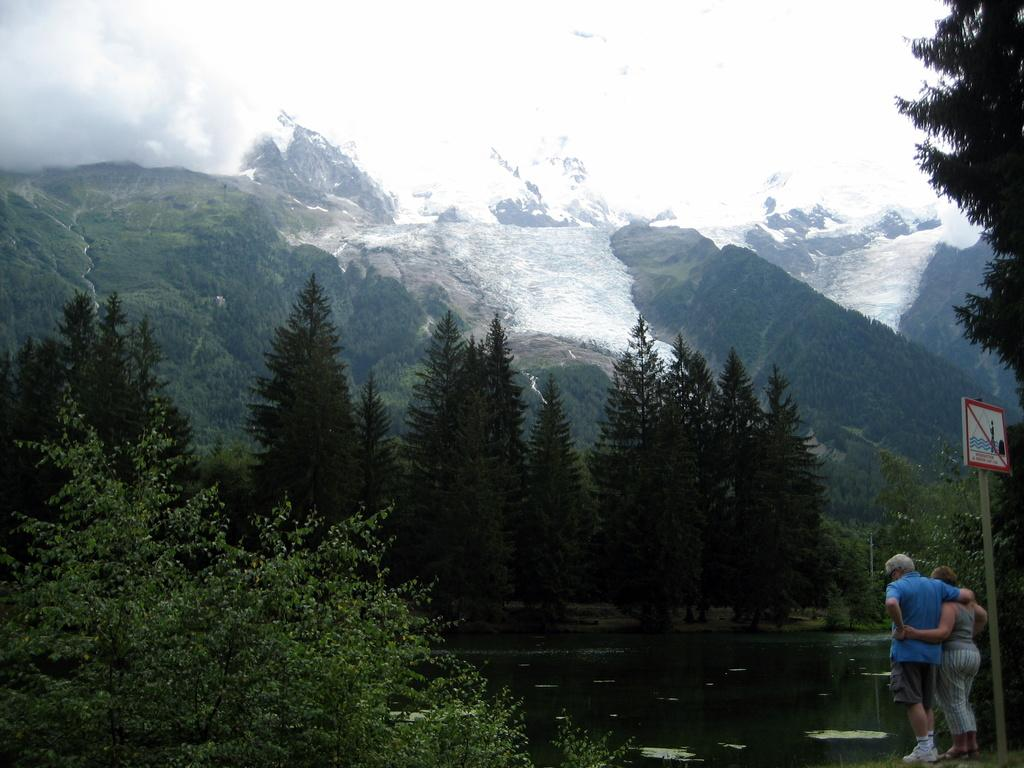What are the people in the image doing? The persons standing on the ground in the image are likely standing or waiting. What is the purpose of the sign board in the image? The sign board in the image may provide information or directions to the people. What is the natural element visible in the image? Water and trees are visible in the image. What can be seen in the background of the image? The sky is visible in the background of the image. How does the sun pull the water in the image? The image does not show the sun or any interaction between the sun and the water. The sun's gravitational pull on the water is not visible in the image. 